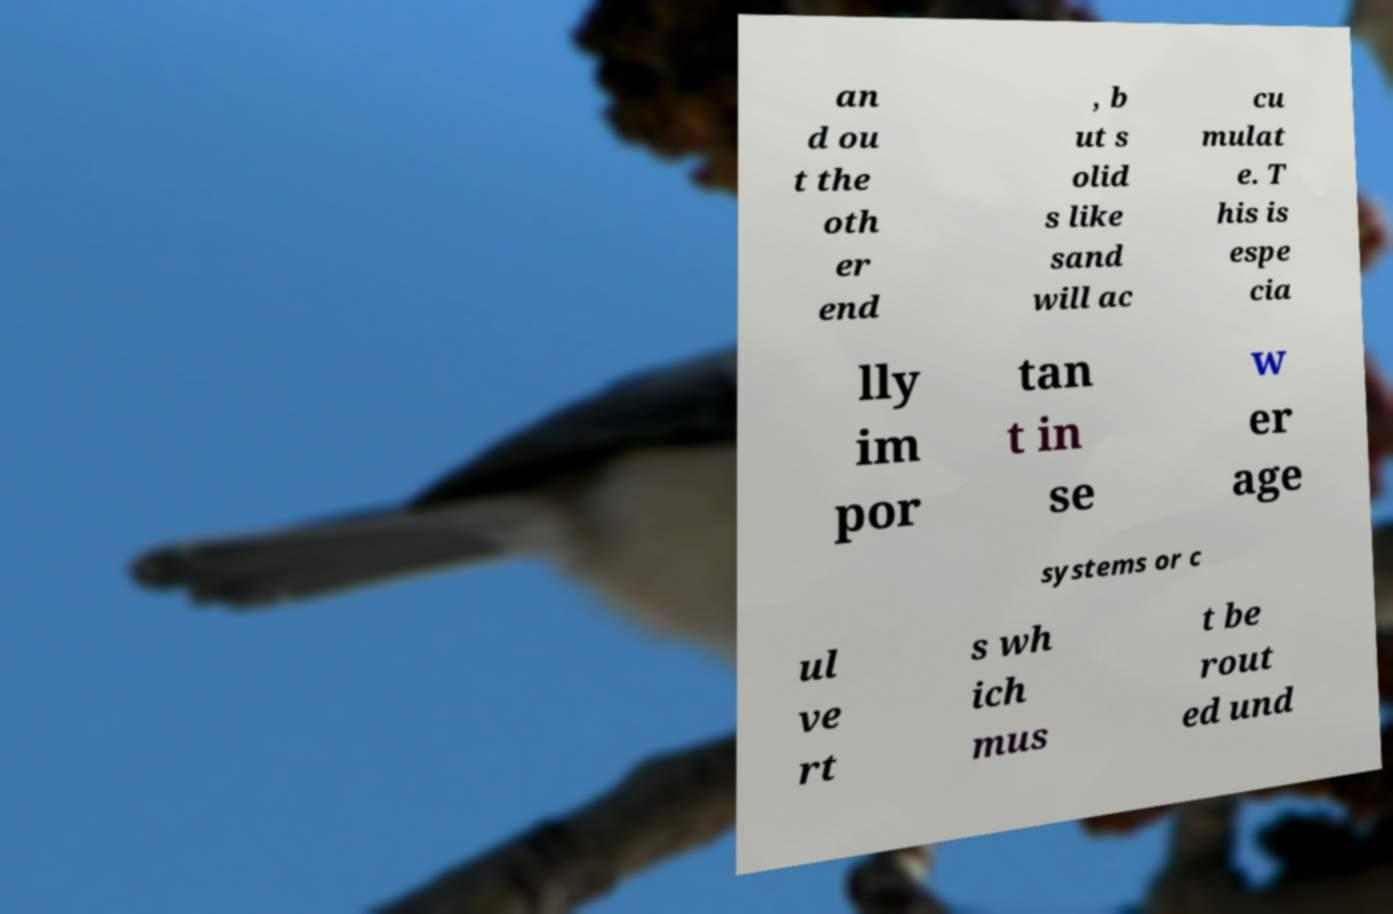What messages or text are displayed in this image? I need them in a readable, typed format. an d ou t the oth er end , b ut s olid s like sand will ac cu mulat e. T his is espe cia lly im por tan t in se w er age systems or c ul ve rt s wh ich mus t be rout ed und 